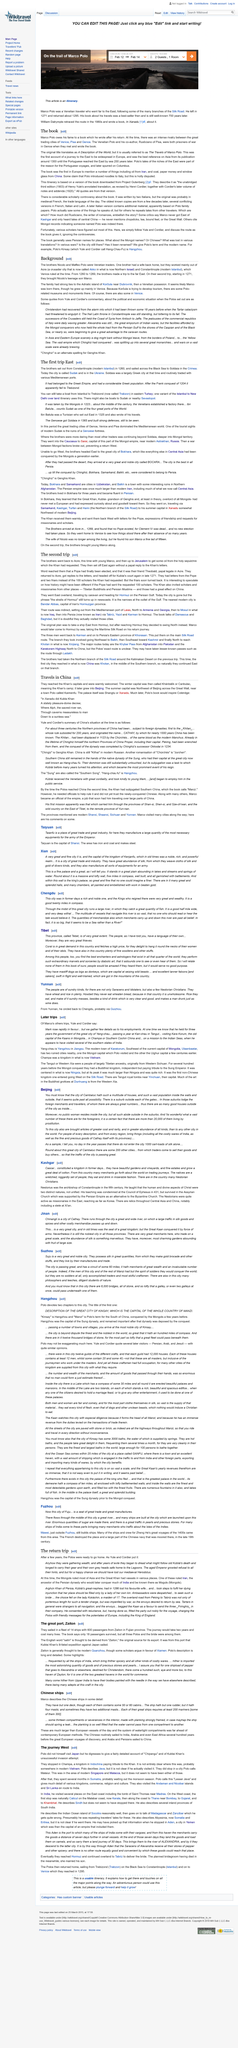Mention a couple of crucial points in this snapshot. Marco Polo's co-author on "The Travels of Marco Polo" was Rusticiano of Pisa, as stated in the book. The Travels of Marco Polo" was first published around 1300. The original title of 'The Travels of Marco Polo' was 'A Description of the World,' which was later changed to its more well-known title. 